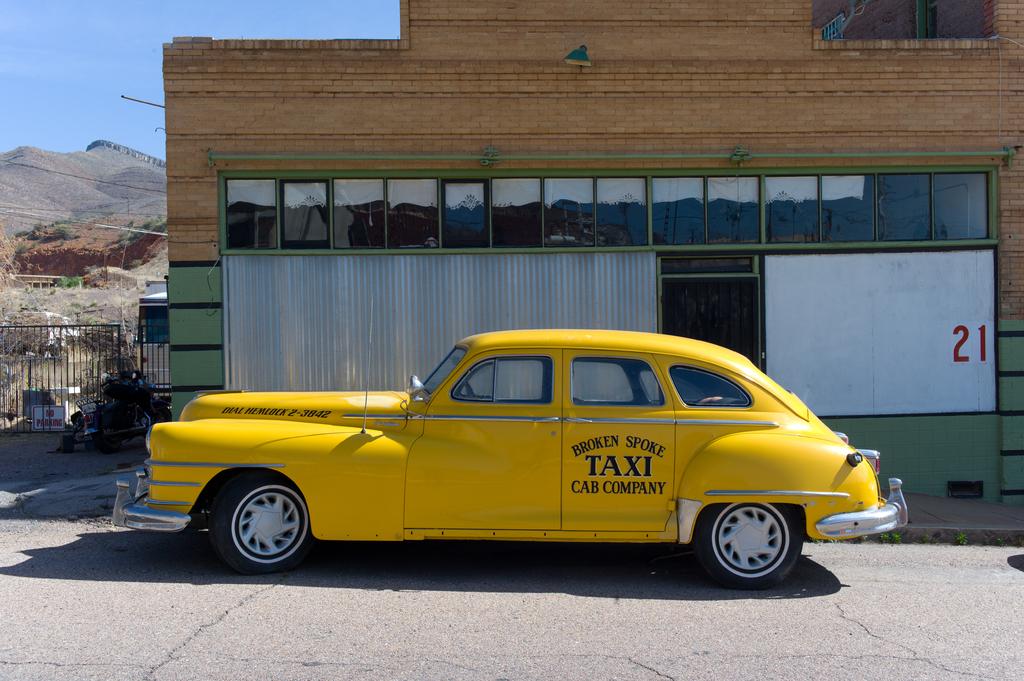What is the yellow car used for?
Make the answer very short. Taxi. What company is the car with?
Give a very brief answer. Broken spoke cab company. 